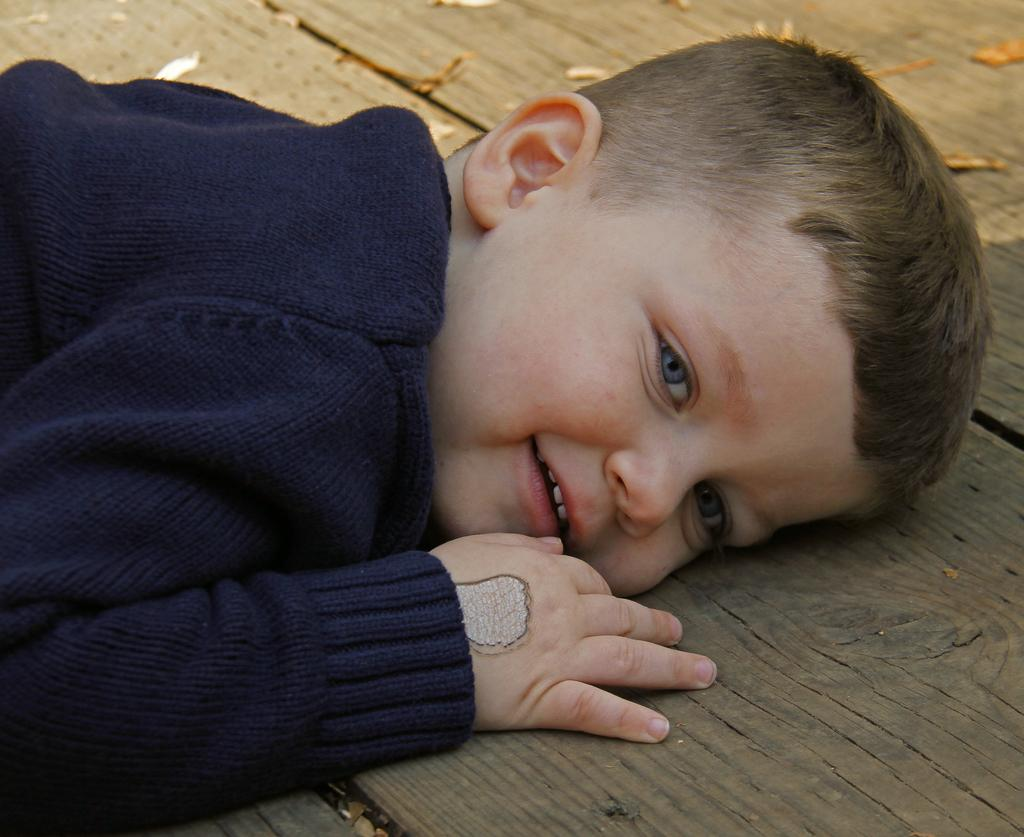Who is the main subject in the image? There is a boy in the image. What is the boy doing in the image? The boy is laying on a wooden surface. What is the boy's facial expression in the image? The boy is smiling. What is the boy wearing in the image? The boy is wearing a blue color sweater. What type of adjustment does the boy make to the planes in the image? There are no planes present in the image, so no adjustments can be made. 